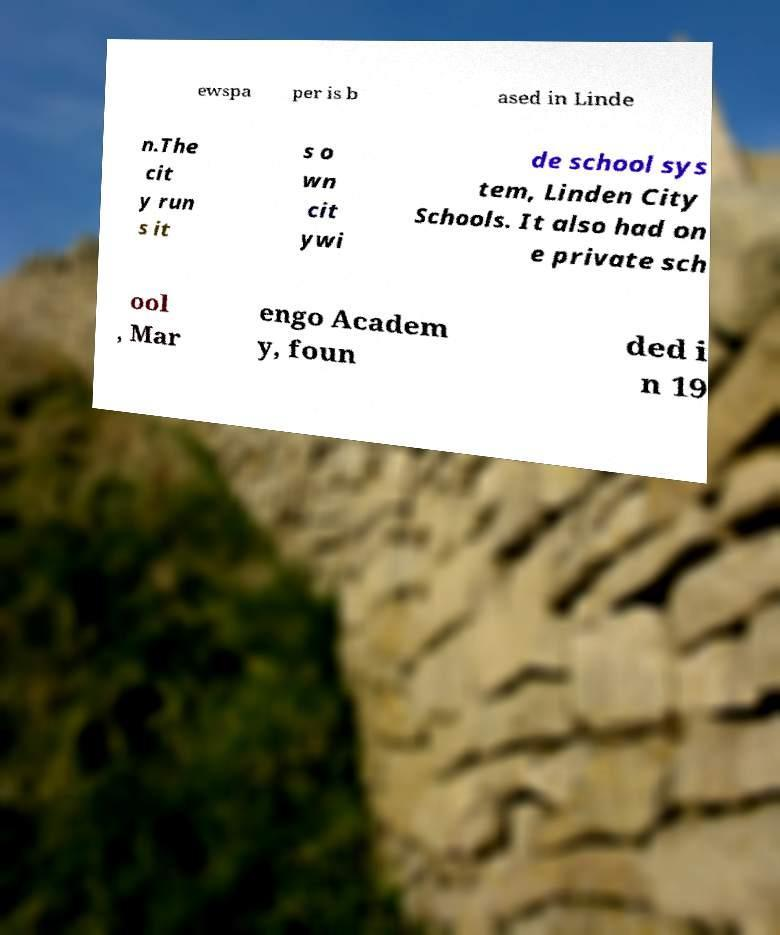For documentation purposes, I need the text within this image transcribed. Could you provide that? ewspa per is b ased in Linde n.The cit y run s it s o wn cit ywi de school sys tem, Linden City Schools. It also had on e private sch ool , Mar engo Academ y, foun ded i n 19 